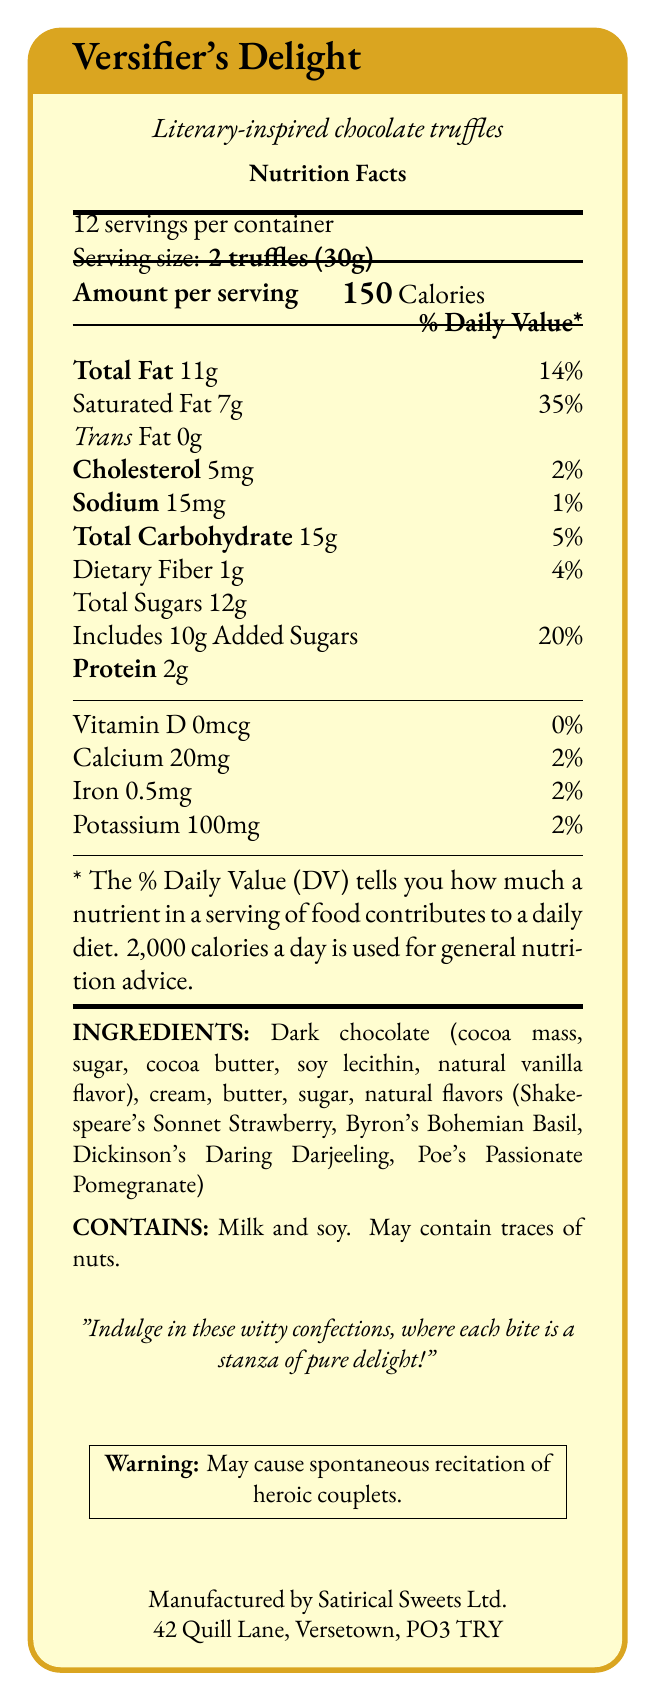what is the serving size? The serving size is specified as "2 truffles (30g)" in the document.
Answer: 2 truffles (30g) how many servings are in a container? The document states that there are 12 servings per container.
Answer: 12 how many calories are in one serving of Versifier's Delight truffles? The document clearly mentions "150 Calories" under the "Amount per serving" section.
Answer: 150 calories what is the total fat content in one serving? The document lists "Total Fat" as 11g per serving.
Answer: 11g what percentage of the daily value is the saturated fat in one serving? The document specifies that the saturated fat is 7g, which is 35% of the daily value.
Answer: 35% which poet's name is used for the strawberry flavor? A. Shakespeare B. Byron C. Dickinson D. Poe The document states "natural flavors (Shakespeare's Sonnet Strawberry, Byron's Bohemian Basil, Dickinson's Daring Darjeeling, Poe's Passionate Pomegranate)".
Answer: A. Shakespeare what is the amount of cholesterol in one serving? The document states that the cholesterol content is 5mg per serving.
Answer: 5mg does the product contain any trans fat? The document lists Trans Fat as 0g, indicating that there is no trans fat in the product.
Answer: No which vitamins and minerals are present in small quantities in the product? I. Vitamin D II. Calcium III. Iron IV. Potassium The document states the amounts and daily values for Vitamin D, Calcium, Iron, and Potassium as: Vitamin D 0mcg (0%), Calcium 20mg (2%), Iron 0.5mg (2%), and Potassium 100mg (2%).
Answer: I, II, III, IV does the product contain nuts? The document mentions that the product "May contain traces of nuts."
Answer: May contain summarize the document in one or two sentences. The document is a detailed nutrition facts label for a creative chocolate product, noting its nutritional content and ingredients, while also incorporating playful literary remarks and warnings.
Answer: The document provides the nutrition facts for "Versifier's Delight" literary-inspired chocolate truffles. It details the serving size, calorie content, various nutritional values, ingredients, allergens, and includes whimsical notes related to poetry. how much dietary fiber is in one serving? The document specifies that there is 1g of dietary fiber per serving.
Answer: 1g what address is given for the manufacturer? The document lists the manufacturer's address as 42 Quill Lane, Versetown, PO3 TRY.
Answer: 42 Quill Lane, Versetown, PO3 TRY which flavor is associated with Dickinson? The ingredients list includes "natural flavors (Dickinson's Daring Darjeeling)" referring to Emily Dickinson.
Answer: Dickinson's Daring Darjeeling what are the main ingredients in the dark chocolate? The document specifies the main ingredients in dark chocolate as "cocoa mass, sugar, cocoa butter, soy lecithin, natural vanilla flavor".
Answer: Cocoa mass, sugar, cocoa butter, soy lecithin, natural vanilla flavor what is the total carbohydrate content per serving? The document states that the total carbohydrate content is 15g per serving.
Answer: 15g what is the poetic quip mentioned in the document? A. Will make you rhyme B. May cause spontaneous recitation of heroic couplets C. Induce poetic musings The document includes the quip "Warning: May cause spontaneous recitation of heroic couplets."
Answer: B. May cause spontaneous recitation of heroic couplets which essential nutrient is absent in this product? The document lists Vitamin D as 0mcg, corresponding to 0% of the daily value.
Answer: Vitamin D how would this product be useful for a specific literary-themed event? The product's description and whimsical notes suggest it is designed to entertain and delight, making it apt for a literary-themed event.
Answer: Indulge in these witty confections, where each bite is a stanza of pure delight! how many added sugars are in one serving? The document indicates that there are 10g of added sugars per serving.
Answer: 10g is there enough information provided to know the price of this product? There is no information regarding the price of the product in the document.
Answer: No 